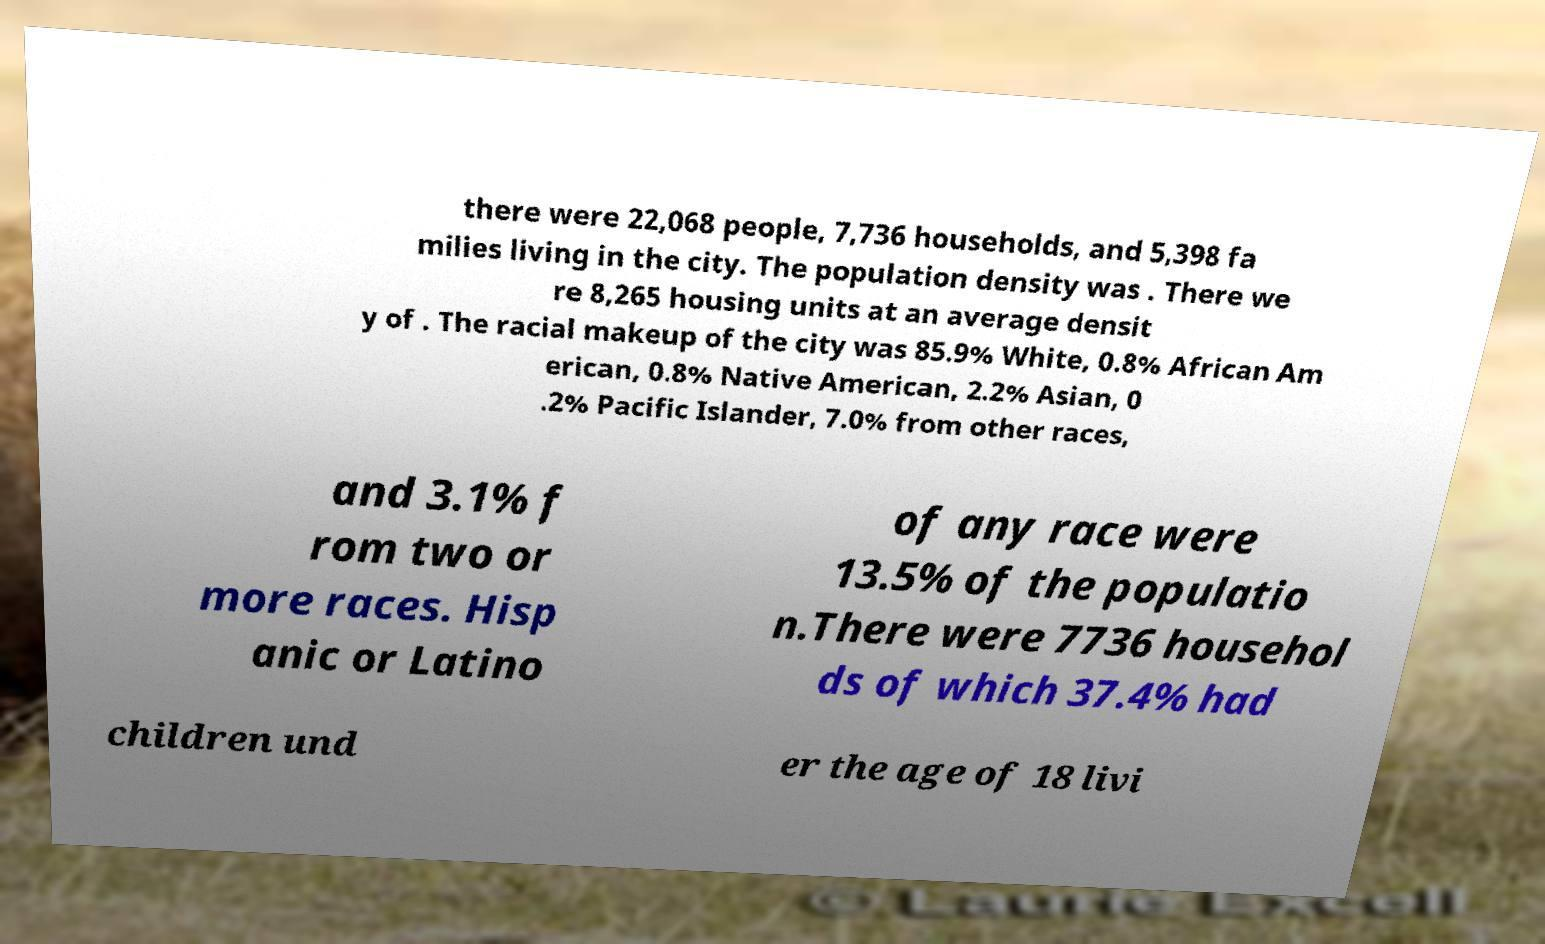For documentation purposes, I need the text within this image transcribed. Could you provide that? there were 22,068 people, 7,736 households, and 5,398 fa milies living in the city. The population density was . There we re 8,265 housing units at an average densit y of . The racial makeup of the city was 85.9% White, 0.8% African Am erican, 0.8% Native American, 2.2% Asian, 0 .2% Pacific Islander, 7.0% from other races, and 3.1% f rom two or more races. Hisp anic or Latino of any race were 13.5% of the populatio n.There were 7736 househol ds of which 37.4% had children und er the age of 18 livi 